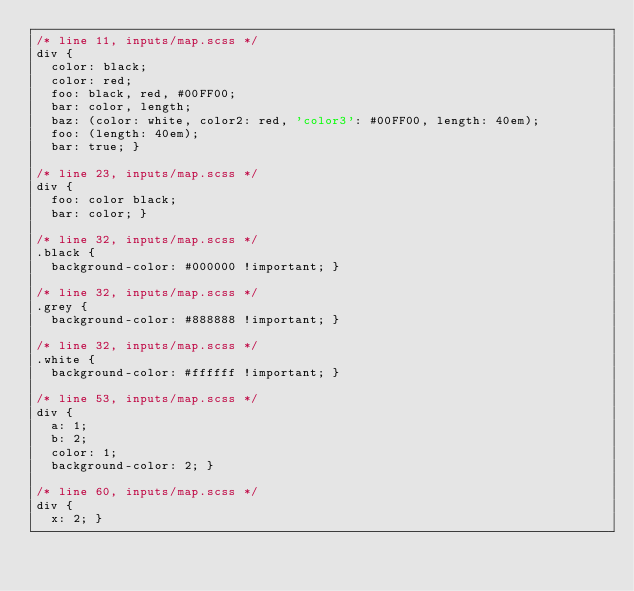Convert code to text. <code><loc_0><loc_0><loc_500><loc_500><_CSS_>/* line 11, inputs/map.scss */
div {
  color: black;
  color: red;
  foo: black, red, #00FF00;
  bar: color, length;
  baz: (color: white, color2: red, 'color3': #00FF00, length: 40em);
  foo: (length: 40em);
  bar: true; }

/* line 23, inputs/map.scss */
div {
  foo: color black;
  bar: color; }

/* line 32, inputs/map.scss */
.black {
  background-color: #000000 !important; }

/* line 32, inputs/map.scss */
.grey {
  background-color: #888888 !important; }

/* line 32, inputs/map.scss */
.white {
  background-color: #ffffff !important; }

/* line 53, inputs/map.scss */
div {
  a: 1;
  b: 2;
  color: 1;
  background-color: 2; }

/* line 60, inputs/map.scss */
div {
  x: 2; }
</code> 